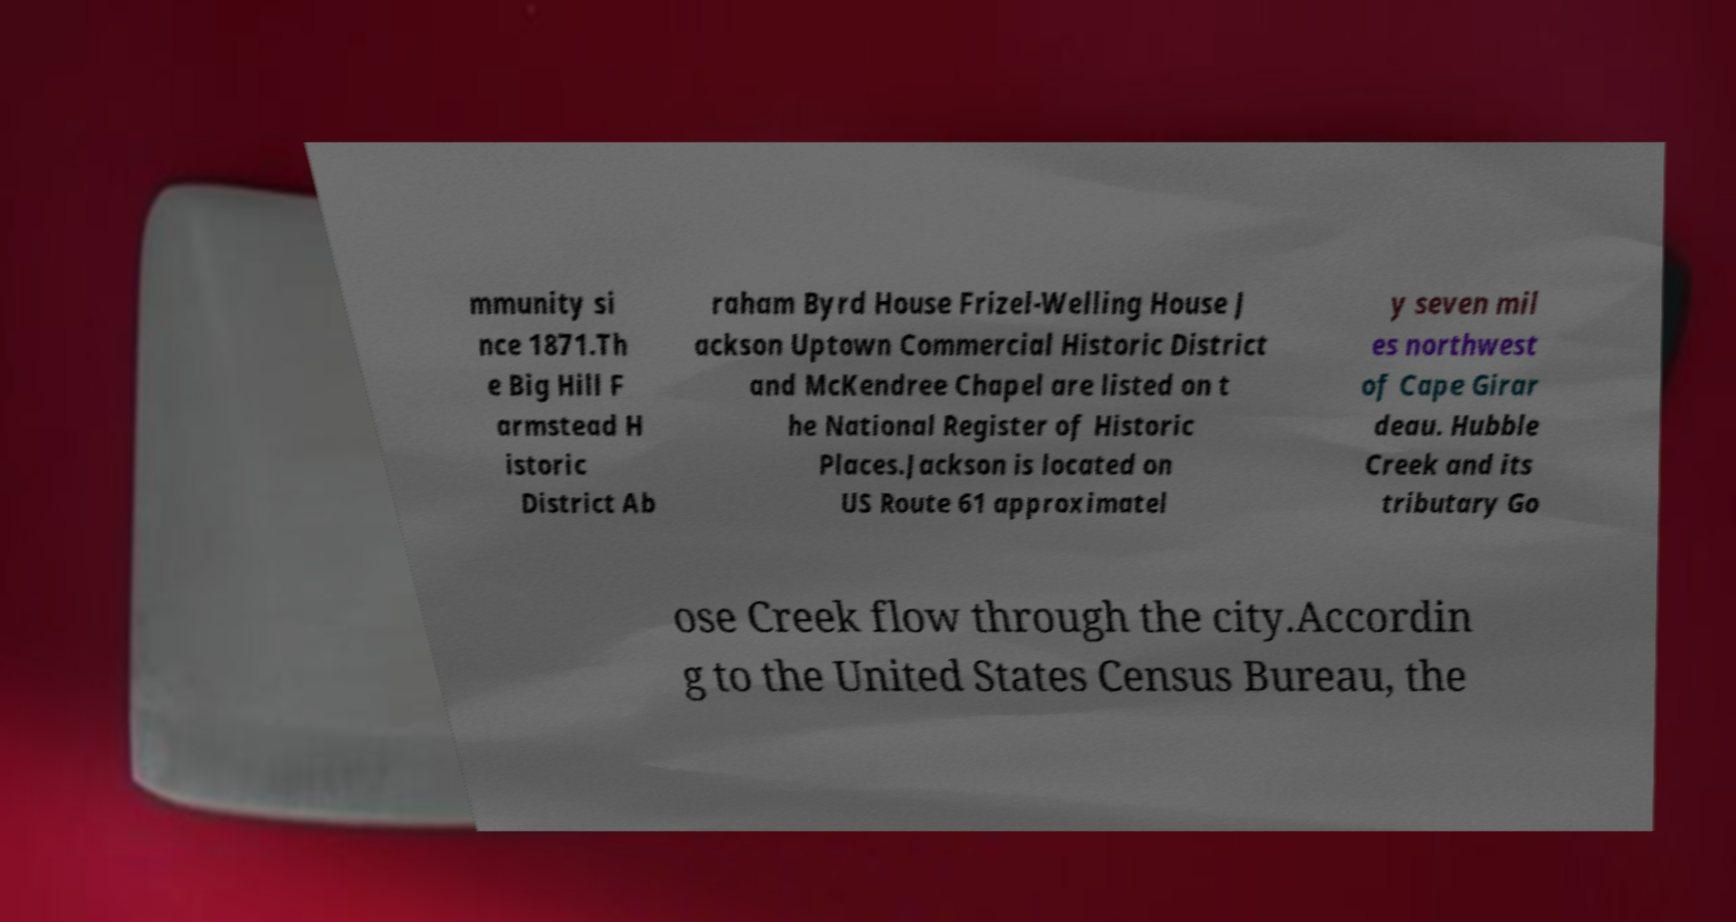Please identify and transcribe the text found in this image. mmunity si nce 1871.Th e Big Hill F armstead H istoric District Ab raham Byrd House Frizel-Welling House J ackson Uptown Commercial Historic District and McKendree Chapel are listed on t he National Register of Historic Places.Jackson is located on US Route 61 approximatel y seven mil es northwest of Cape Girar deau. Hubble Creek and its tributary Go ose Creek flow through the city.Accordin g to the United States Census Bureau, the 